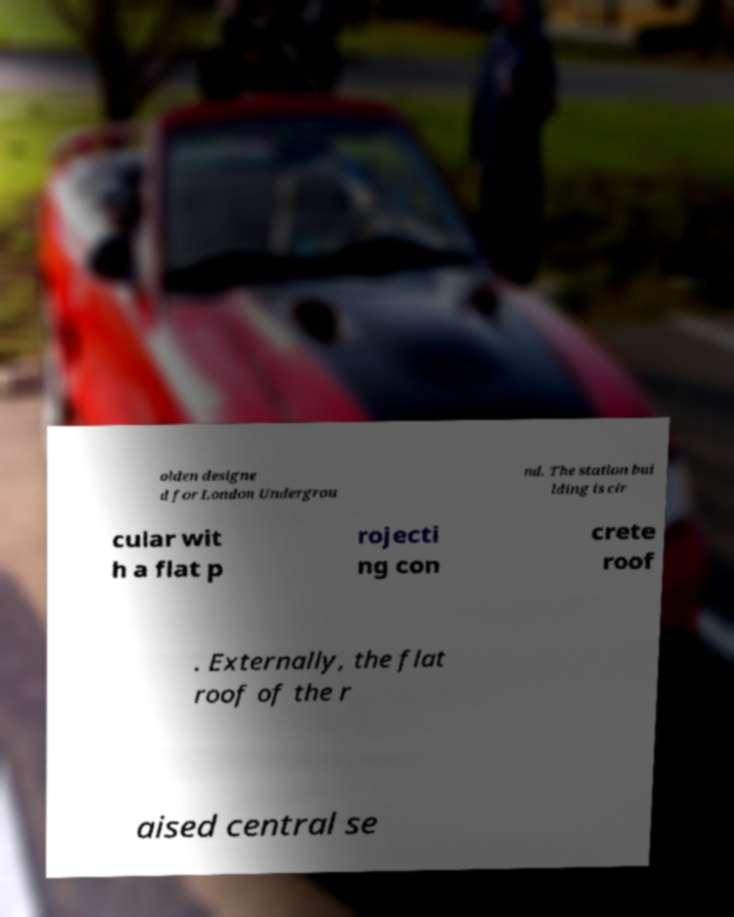For documentation purposes, I need the text within this image transcribed. Could you provide that? olden designe d for London Undergrou nd. The station bui lding is cir cular wit h a flat p rojecti ng con crete roof . Externally, the flat roof of the r aised central se 